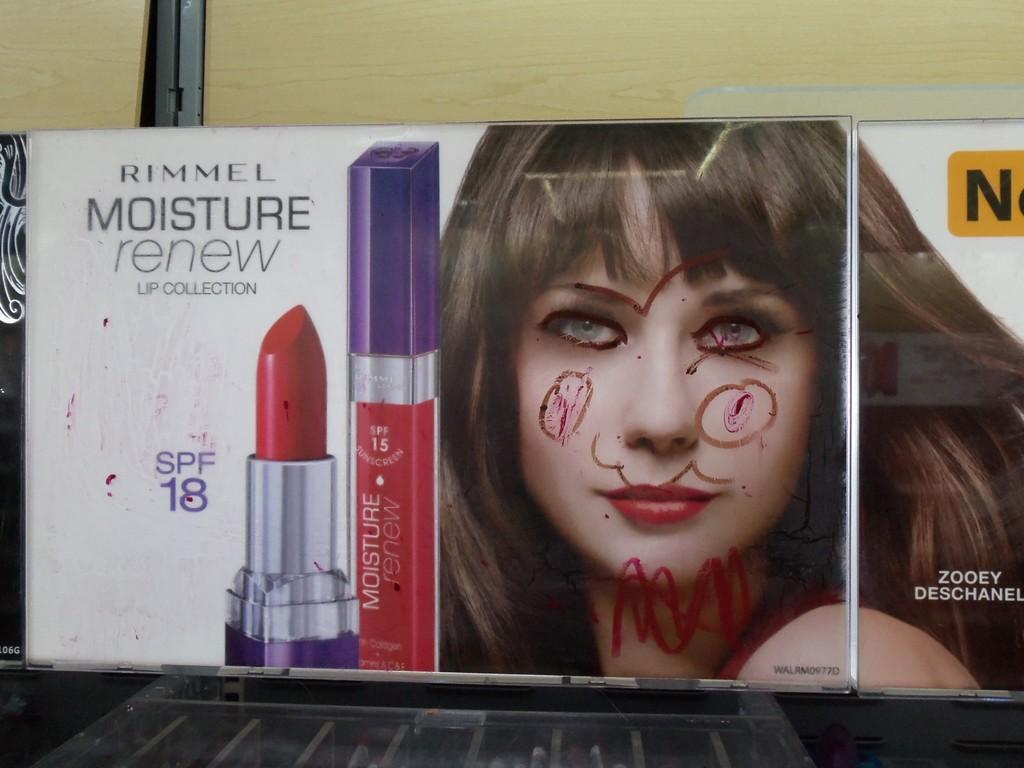In one or two sentences, can you explain what this image depicts? In this image, there is an advertisement board contains a person and lipstick. 